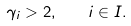Convert formula to latex. <formula><loc_0><loc_0><loc_500><loc_500>\gamma _ { i } > 2 , \quad i \in I .</formula> 